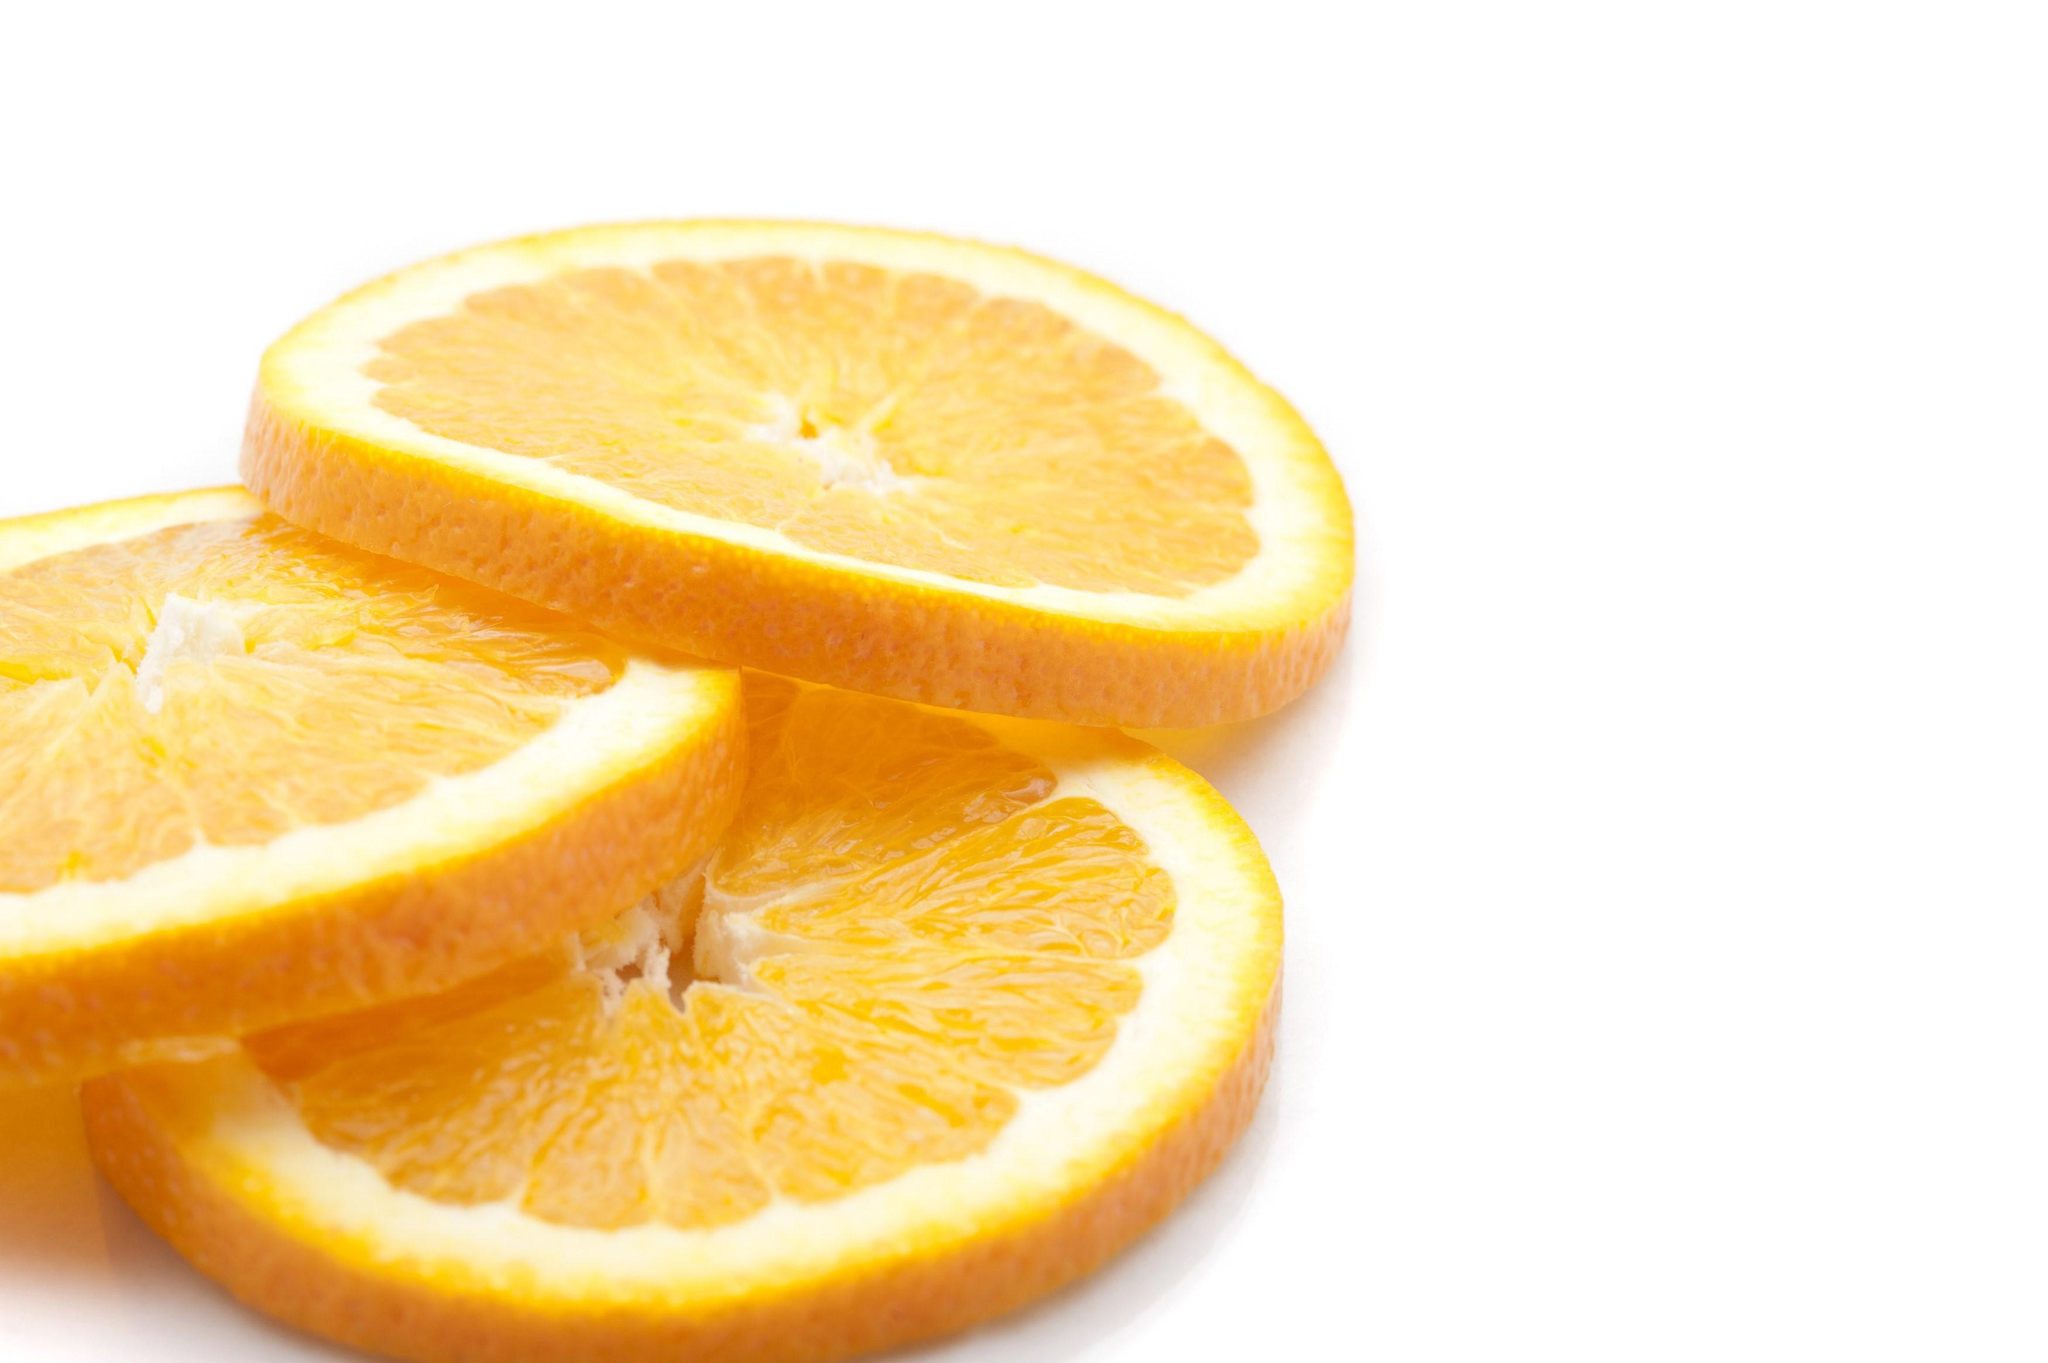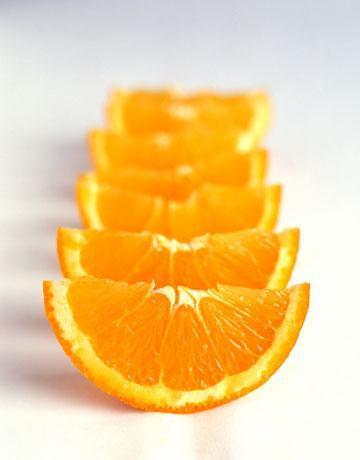The first image is the image on the left, the second image is the image on the right. For the images displayed, is the sentence "In one image, the oranges are quartered and in the other they are sliced circles." factually correct? Answer yes or no. Yes. The first image is the image on the left, the second image is the image on the right. Considering the images on both sides, is "There is fruit on a white surface." valid? Answer yes or no. Yes. 